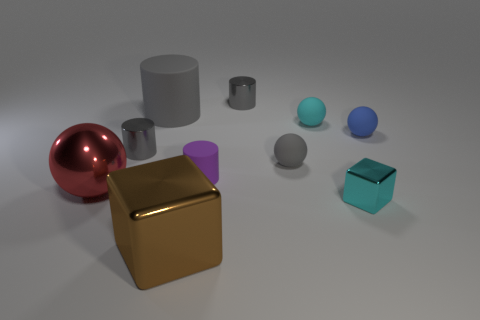There is a red thing; does it have the same shape as the cyan matte object to the right of the tiny purple cylinder?
Provide a short and direct response. Yes. Is there a big gray rubber cylinder that is on the left side of the tiny thing that is to the right of the cyan thing in front of the large red object?
Offer a very short reply. Yes. What size is the cyan object that is behind the red thing?
Ensure brevity in your answer.  Small. There is a red ball that is the same size as the brown metallic object; what is it made of?
Your answer should be very brief. Metal. Does the purple object have the same shape as the large brown object?
Your response must be concise. No. How many objects are either purple rubber objects or balls on the right side of the large gray cylinder?
Your answer should be very brief. 4. There is a tiny sphere that is the same color as the big cylinder; what is its material?
Offer a terse response. Rubber. Do the cyan object that is in front of the red sphere and the shiny sphere have the same size?
Offer a terse response. No. There is a gray matte object in front of the tiny gray cylinder in front of the tiny blue object; what number of big shiny balls are right of it?
Your response must be concise. 0. How many red things are large matte things or metal balls?
Your response must be concise. 1. 